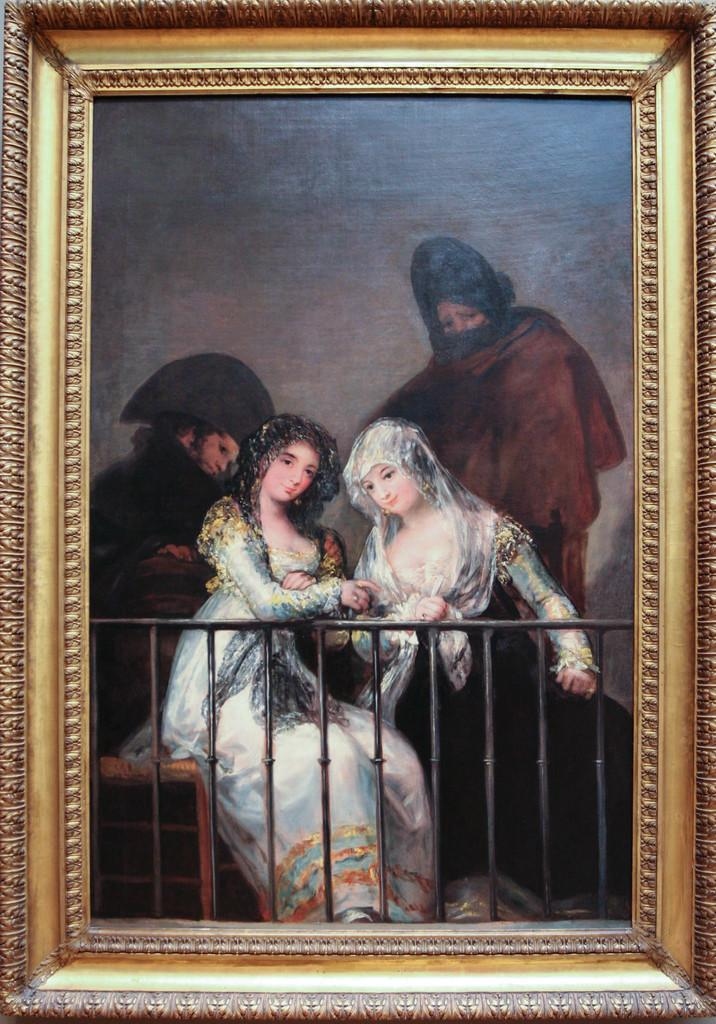What is the main object in the image? There is a frame in the image. What can be seen inside the frame? There are people inside the frame. What type of root can be seen growing through the frame in the image? There is no root visible in the image; it only features a frame with people inside. 